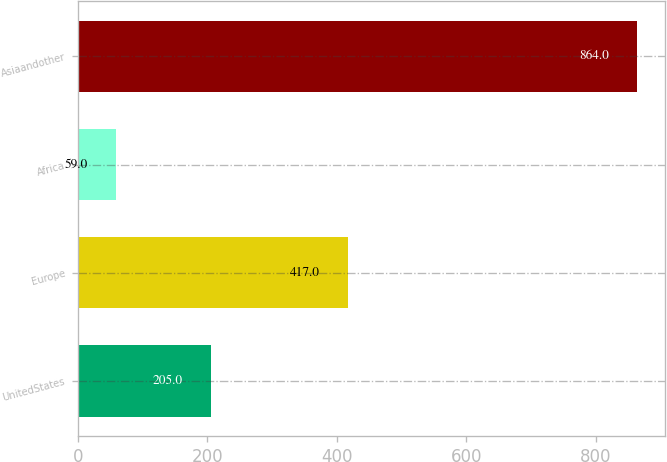<chart> <loc_0><loc_0><loc_500><loc_500><bar_chart><fcel>UnitedStates<fcel>Europe<fcel>Africa<fcel>Asiaandother<nl><fcel>205<fcel>417<fcel>59<fcel>864<nl></chart> 